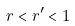Convert formula to latex. <formula><loc_0><loc_0><loc_500><loc_500>r < r ^ { \prime } < 1</formula> 